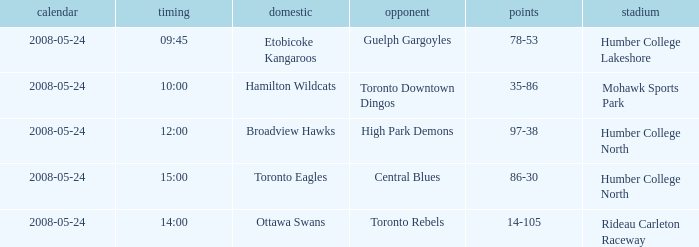On what day was the game that ended in a score of 97-38? 2008-05-24. 